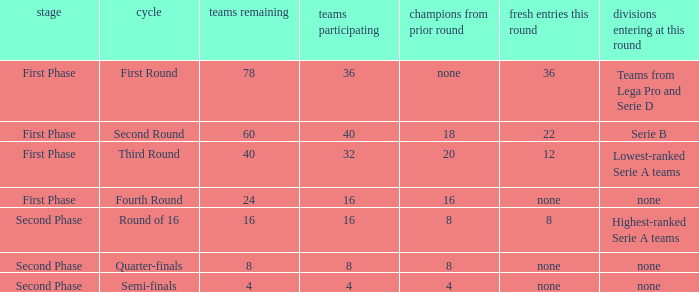When looking at new entries this round and seeing 8; what number in total is there for clubs remaining? 1.0. 